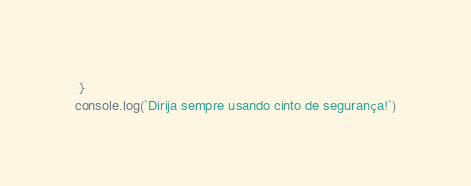Convert code to text. <code><loc_0><loc_0><loc_500><loc_500><_JavaScript_> }
console.log(`Dirija sempre usando cinto de segurança!`)</code> 